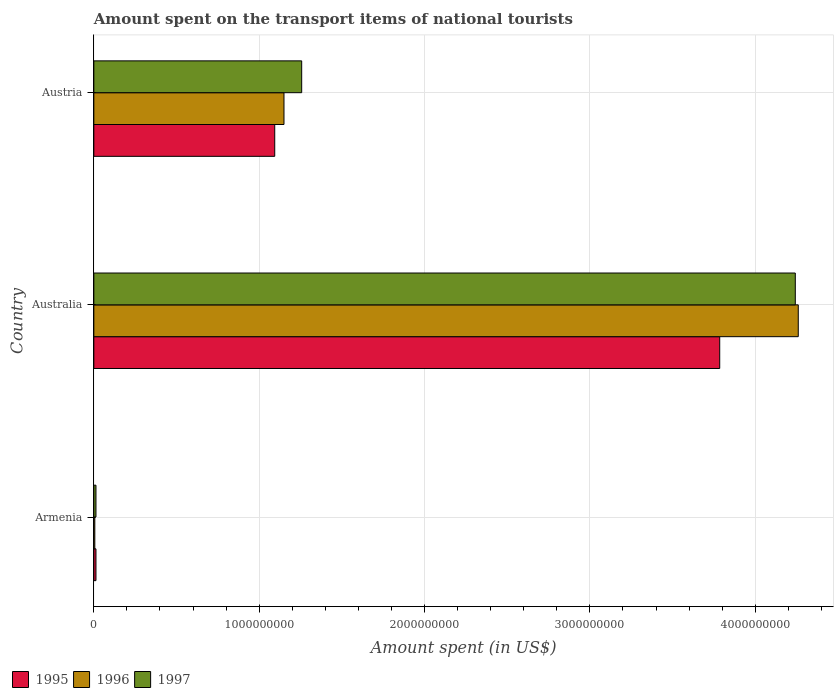How many groups of bars are there?
Your answer should be compact. 3. How many bars are there on the 1st tick from the top?
Your answer should be compact. 3. How many bars are there on the 3rd tick from the bottom?
Ensure brevity in your answer.  3. What is the amount spent on the transport items of national tourists in 1995 in Australia?
Provide a short and direct response. 3.78e+09. Across all countries, what is the maximum amount spent on the transport items of national tourists in 1996?
Ensure brevity in your answer.  4.26e+09. Across all countries, what is the minimum amount spent on the transport items of national tourists in 1997?
Make the answer very short. 1.30e+07. In which country was the amount spent on the transport items of national tourists in 1996 minimum?
Ensure brevity in your answer.  Armenia. What is the total amount spent on the transport items of national tourists in 1996 in the graph?
Provide a short and direct response. 5.42e+09. What is the difference between the amount spent on the transport items of national tourists in 1996 in Australia and that in Austria?
Offer a very short reply. 3.11e+09. What is the difference between the amount spent on the transport items of national tourists in 1996 in Armenia and the amount spent on the transport items of national tourists in 1995 in Austria?
Give a very brief answer. -1.09e+09. What is the average amount spent on the transport items of national tourists in 1995 per country?
Your response must be concise. 1.63e+09. What is the difference between the amount spent on the transport items of national tourists in 1997 and amount spent on the transport items of national tourists in 1995 in Armenia?
Keep it short and to the point. 0. In how many countries, is the amount spent on the transport items of national tourists in 1996 greater than 3600000000 US$?
Give a very brief answer. 1. What is the ratio of the amount spent on the transport items of national tourists in 1996 in Armenia to that in Australia?
Your response must be concise. 0. Is the amount spent on the transport items of national tourists in 1997 in Armenia less than that in Austria?
Your answer should be very brief. Yes. Is the difference between the amount spent on the transport items of national tourists in 1997 in Australia and Austria greater than the difference between the amount spent on the transport items of national tourists in 1995 in Australia and Austria?
Keep it short and to the point. Yes. What is the difference between the highest and the second highest amount spent on the transport items of national tourists in 1997?
Your answer should be compact. 2.98e+09. What is the difference between the highest and the lowest amount spent on the transport items of national tourists in 1997?
Your answer should be very brief. 4.23e+09. Is the sum of the amount spent on the transport items of national tourists in 1995 in Armenia and Australia greater than the maximum amount spent on the transport items of national tourists in 1997 across all countries?
Provide a short and direct response. No. What does the 3rd bar from the bottom in Australia represents?
Make the answer very short. 1997. Is it the case that in every country, the sum of the amount spent on the transport items of national tourists in 1996 and amount spent on the transport items of national tourists in 1995 is greater than the amount spent on the transport items of national tourists in 1997?
Your answer should be very brief. Yes. How many bars are there?
Keep it short and to the point. 9. Are all the bars in the graph horizontal?
Your answer should be very brief. Yes. What is the difference between two consecutive major ticks on the X-axis?
Your answer should be compact. 1.00e+09. Does the graph contain any zero values?
Ensure brevity in your answer.  No. Does the graph contain grids?
Offer a terse response. Yes. Where does the legend appear in the graph?
Ensure brevity in your answer.  Bottom left. How many legend labels are there?
Offer a terse response. 3. What is the title of the graph?
Offer a terse response. Amount spent on the transport items of national tourists. What is the label or title of the X-axis?
Provide a short and direct response. Amount spent (in US$). What is the Amount spent (in US$) in 1995 in Armenia?
Give a very brief answer. 1.30e+07. What is the Amount spent (in US$) in 1996 in Armenia?
Provide a short and direct response. 6.00e+06. What is the Amount spent (in US$) of 1997 in Armenia?
Your answer should be very brief. 1.30e+07. What is the Amount spent (in US$) in 1995 in Australia?
Offer a very short reply. 3.78e+09. What is the Amount spent (in US$) of 1996 in Australia?
Your answer should be compact. 4.26e+09. What is the Amount spent (in US$) in 1997 in Australia?
Offer a very short reply. 4.24e+09. What is the Amount spent (in US$) in 1995 in Austria?
Your response must be concise. 1.09e+09. What is the Amount spent (in US$) of 1996 in Austria?
Your answer should be compact. 1.15e+09. What is the Amount spent (in US$) of 1997 in Austria?
Ensure brevity in your answer.  1.26e+09. Across all countries, what is the maximum Amount spent (in US$) of 1995?
Offer a terse response. 3.78e+09. Across all countries, what is the maximum Amount spent (in US$) in 1996?
Keep it short and to the point. 4.26e+09. Across all countries, what is the maximum Amount spent (in US$) of 1997?
Provide a short and direct response. 4.24e+09. Across all countries, what is the minimum Amount spent (in US$) of 1995?
Your answer should be compact. 1.30e+07. Across all countries, what is the minimum Amount spent (in US$) in 1996?
Give a very brief answer. 6.00e+06. Across all countries, what is the minimum Amount spent (in US$) of 1997?
Your response must be concise. 1.30e+07. What is the total Amount spent (in US$) of 1995 in the graph?
Offer a terse response. 4.89e+09. What is the total Amount spent (in US$) of 1996 in the graph?
Provide a succinct answer. 5.42e+09. What is the total Amount spent (in US$) in 1997 in the graph?
Provide a short and direct response. 5.51e+09. What is the difference between the Amount spent (in US$) in 1995 in Armenia and that in Australia?
Your response must be concise. -3.77e+09. What is the difference between the Amount spent (in US$) in 1996 in Armenia and that in Australia?
Offer a terse response. -4.25e+09. What is the difference between the Amount spent (in US$) of 1997 in Armenia and that in Australia?
Give a very brief answer. -4.23e+09. What is the difference between the Amount spent (in US$) of 1995 in Armenia and that in Austria?
Make the answer very short. -1.08e+09. What is the difference between the Amount spent (in US$) of 1996 in Armenia and that in Austria?
Your response must be concise. -1.14e+09. What is the difference between the Amount spent (in US$) in 1997 in Armenia and that in Austria?
Ensure brevity in your answer.  -1.24e+09. What is the difference between the Amount spent (in US$) in 1995 in Australia and that in Austria?
Offer a very short reply. 2.69e+09. What is the difference between the Amount spent (in US$) in 1996 in Australia and that in Austria?
Offer a very short reply. 3.11e+09. What is the difference between the Amount spent (in US$) in 1997 in Australia and that in Austria?
Your response must be concise. 2.98e+09. What is the difference between the Amount spent (in US$) of 1995 in Armenia and the Amount spent (in US$) of 1996 in Australia?
Ensure brevity in your answer.  -4.25e+09. What is the difference between the Amount spent (in US$) in 1995 in Armenia and the Amount spent (in US$) in 1997 in Australia?
Give a very brief answer. -4.23e+09. What is the difference between the Amount spent (in US$) of 1996 in Armenia and the Amount spent (in US$) of 1997 in Australia?
Offer a terse response. -4.24e+09. What is the difference between the Amount spent (in US$) in 1995 in Armenia and the Amount spent (in US$) in 1996 in Austria?
Keep it short and to the point. -1.14e+09. What is the difference between the Amount spent (in US$) in 1995 in Armenia and the Amount spent (in US$) in 1997 in Austria?
Offer a very short reply. -1.24e+09. What is the difference between the Amount spent (in US$) of 1996 in Armenia and the Amount spent (in US$) of 1997 in Austria?
Offer a very short reply. -1.25e+09. What is the difference between the Amount spent (in US$) of 1995 in Australia and the Amount spent (in US$) of 1996 in Austria?
Provide a succinct answer. 2.64e+09. What is the difference between the Amount spent (in US$) in 1995 in Australia and the Amount spent (in US$) in 1997 in Austria?
Make the answer very short. 2.53e+09. What is the difference between the Amount spent (in US$) of 1996 in Australia and the Amount spent (in US$) of 1997 in Austria?
Offer a very short reply. 3.00e+09. What is the average Amount spent (in US$) of 1995 per country?
Offer a very short reply. 1.63e+09. What is the average Amount spent (in US$) of 1996 per country?
Ensure brevity in your answer.  1.81e+09. What is the average Amount spent (in US$) in 1997 per country?
Give a very brief answer. 1.84e+09. What is the difference between the Amount spent (in US$) of 1995 and Amount spent (in US$) of 1997 in Armenia?
Provide a short and direct response. 0. What is the difference between the Amount spent (in US$) in 1996 and Amount spent (in US$) in 1997 in Armenia?
Your answer should be compact. -7.00e+06. What is the difference between the Amount spent (in US$) in 1995 and Amount spent (in US$) in 1996 in Australia?
Your answer should be compact. -4.75e+08. What is the difference between the Amount spent (in US$) in 1995 and Amount spent (in US$) in 1997 in Australia?
Your answer should be very brief. -4.57e+08. What is the difference between the Amount spent (in US$) in 1996 and Amount spent (in US$) in 1997 in Australia?
Your response must be concise. 1.80e+07. What is the difference between the Amount spent (in US$) of 1995 and Amount spent (in US$) of 1996 in Austria?
Ensure brevity in your answer.  -5.60e+07. What is the difference between the Amount spent (in US$) in 1995 and Amount spent (in US$) in 1997 in Austria?
Provide a short and direct response. -1.63e+08. What is the difference between the Amount spent (in US$) of 1996 and Amount spent (in US$) of 1997 in Austria?
Provide a succinct answer. -1.07e+08. What is the ratio of the Amount spent (in US$) of 1995 in Armenia to that in Australia?
Make the answer very short. 0. What is the ratio of the Amount spent (in US$) in 1996 in Armenia to that in Australia?
Your response must be concise. 0. What is the ratio of the Amount spent (in US$) in 1997 in Armenia to that in Australia?
Ensure brevity in your answer.  0. What is the ratio of the Amount spent (in US$) in 1995 in Armenia to that in Austria?
Your answer should be compact. 0.01. What is the ratio of the Amount spent (in US$) in 1996 in Armenia to that in Austria?
Your answer should be compact. 0.01. What is the ratio of the Amount spent (in US$) in 1997 in Armenia to that in Austria?
Offer a terse response. 0.01. What is the ratio of the Amount spent (in US$) in 1995 in Australia to that in Austria?
Make the answer very short. 3.46. What is the ratio of the Amount spent (in US$) in 1996 in Australia to that in Austria?
Provide a succinct answer. 3.7. What is the ratio of the Amount spent (in US$) in 1997 in Australia to that in Austria?
Offer a terse response. 3.37. What is the difference between the highest and the second highest Amount spent (in US$) of 1995?
Ensure brevity in your answer.  2.69e+09. What is the difference between the highest and the second highest Amount spent (in US$) in 1996?
Provide a short and direct response. 3.11e+09. What is the difference between the highest and the second highest Amount spent (in US$) of 1997?
Offer a very short reply. 2.98e+09. What is the difference between the highest and the lowest Amount spent (in US$) of 1995?
Your answer should be very brief. 3.77e+09. What is the difference between the highest and the lowest Amount spent (in US$) of 1996?
Your response must be concise. 4.25e+09. What is the difference between the highest and the lowest Amount spent (in US$) of 1997?
Offer a terse response. 4.23e+09. 